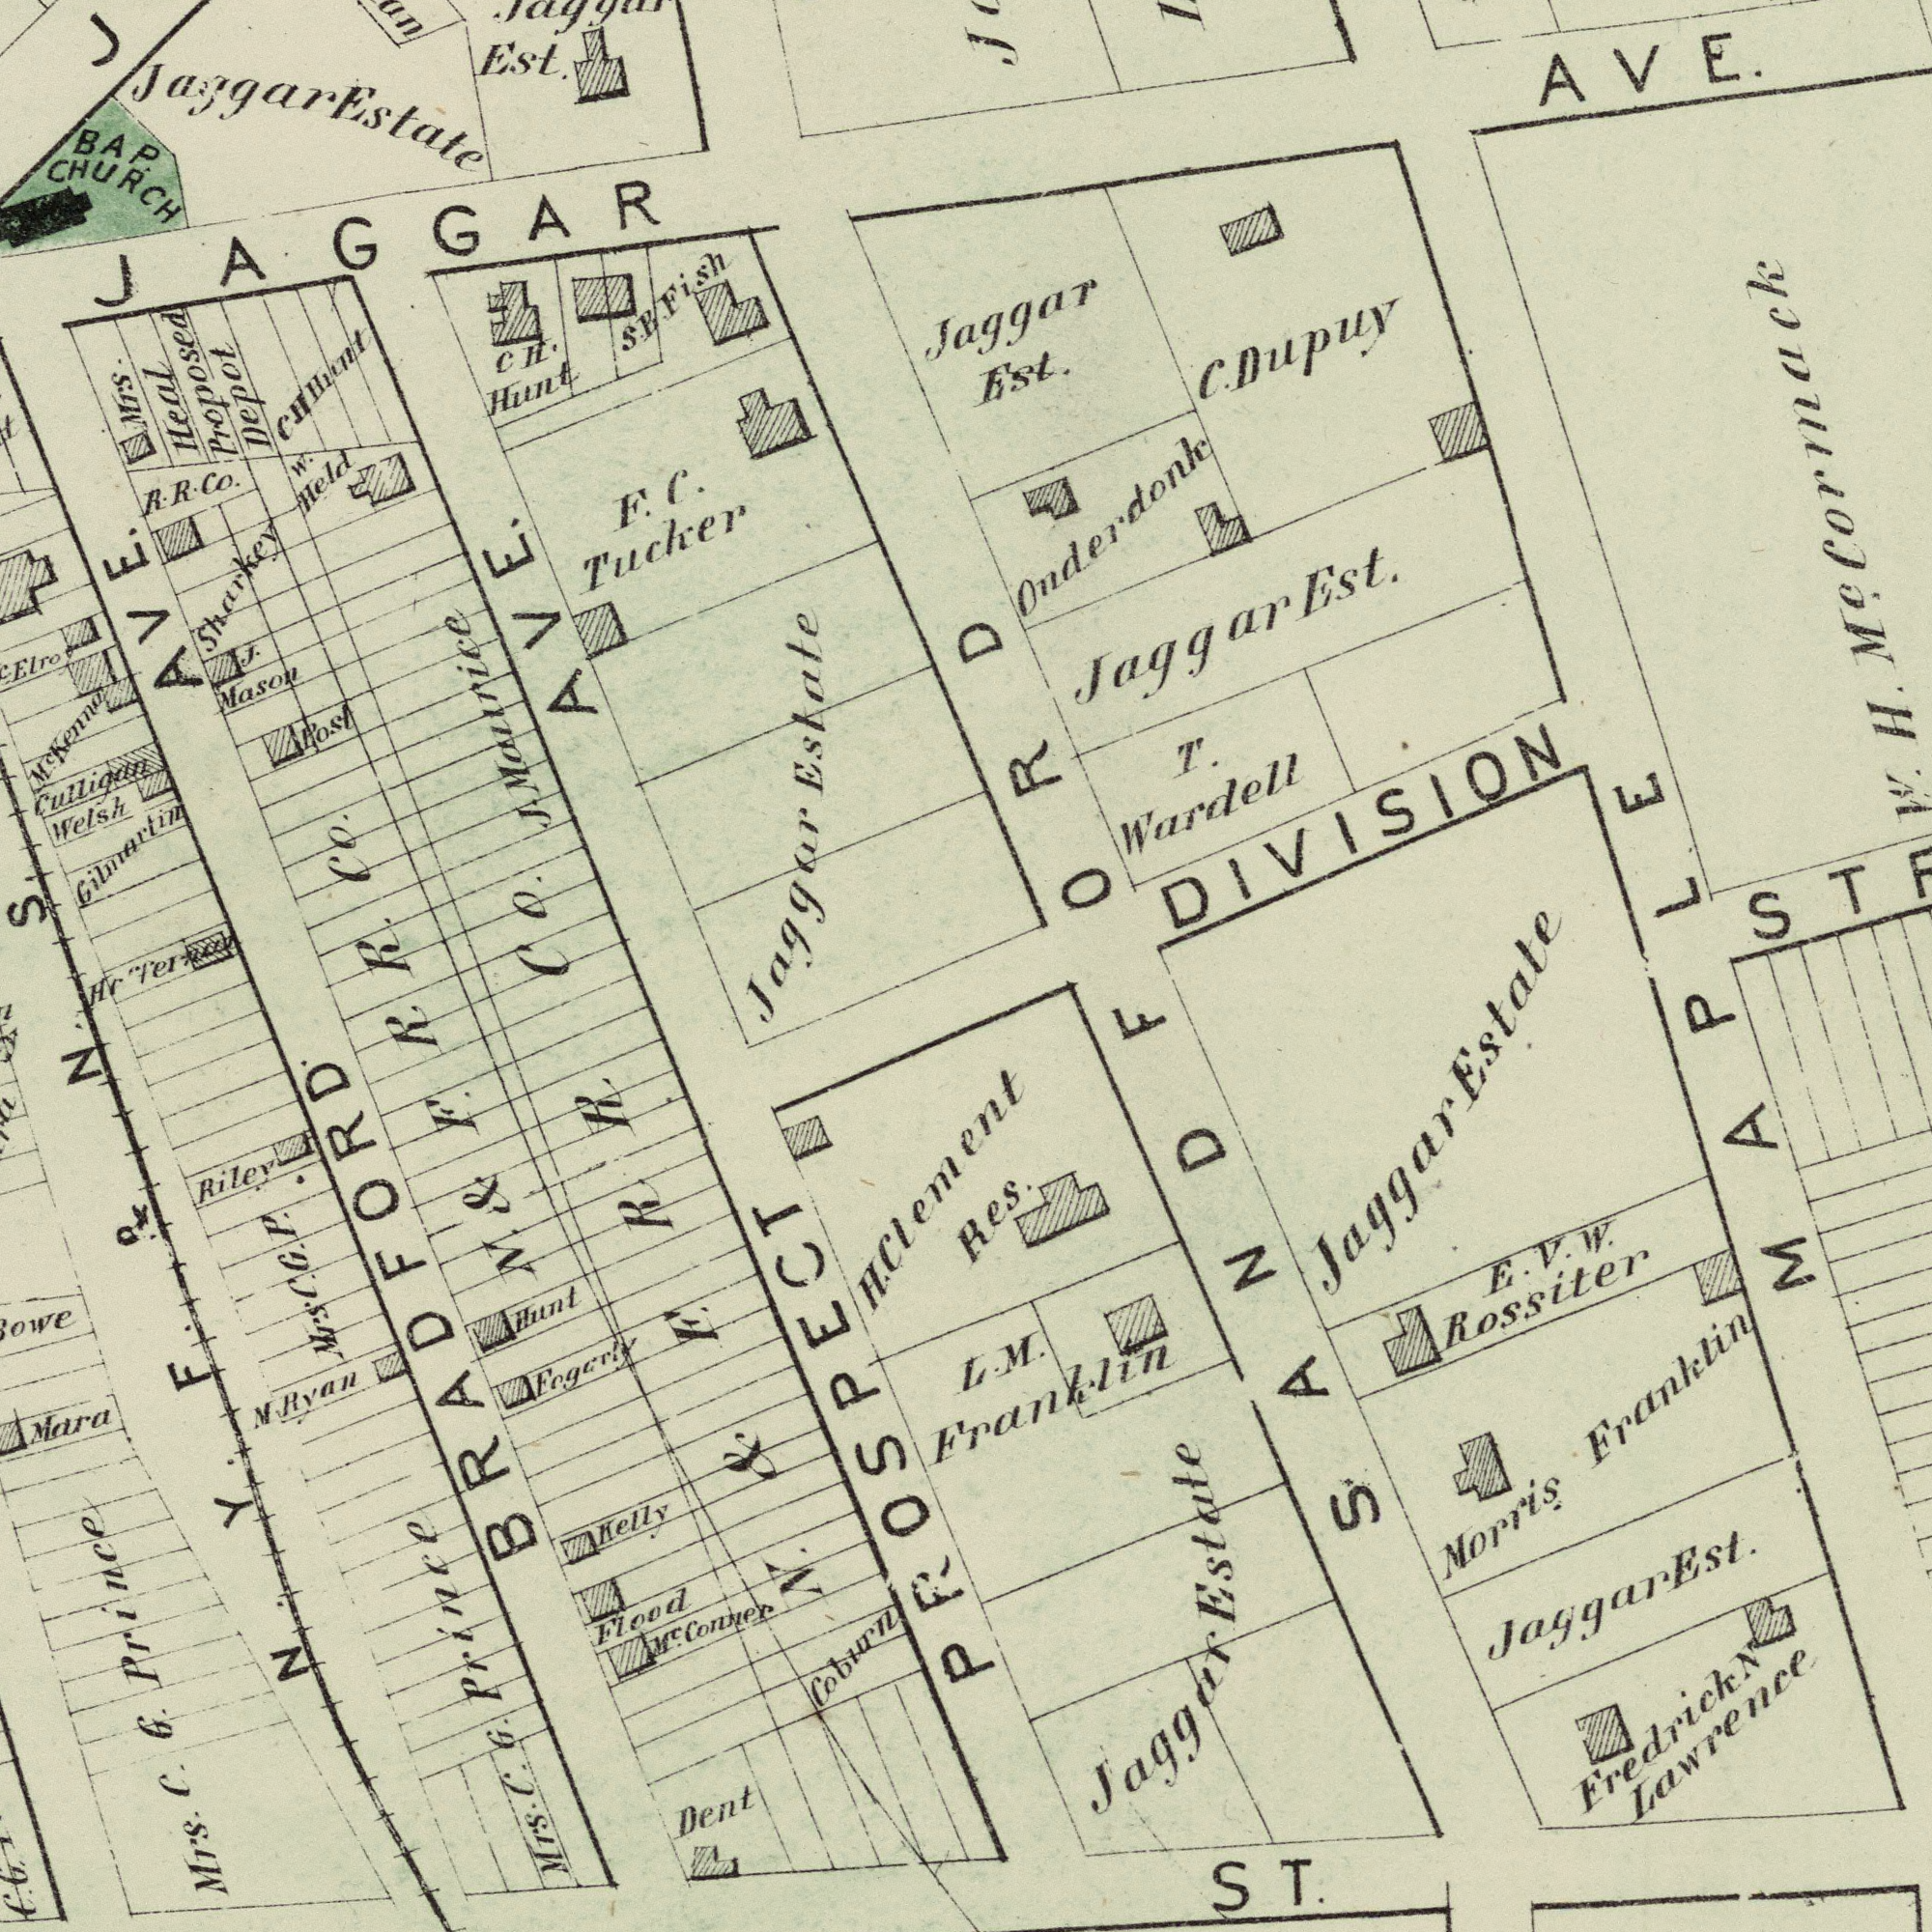What text appears in the top-left area of the image? F. C. Tucker BAP. CHURCH Culligan Welsh Est. W. Held CH. Hunt Gilmartin J. Masou Sharkey Jaggar Estate Post J. Maurice JAGGAR R. R. Co. AVE. Jaggar Estate Mrs. Heal Proposed Depot AVE S. B Fish R. Co. CO. MC Kenna CH H Hiunt S. What text is visible in the lower-left corner? Mara Riley Coburn Mrs. C. G. Prince Helly Dent M Ryan Hr Hunt Flood MC. Conver MTs. C. G. Prince Fogerly H. Clement PROSPECT BRADFORD N. & F. R. N. & E. R. R. Mrs C. G. P. C. G. N. Y. F. R. N. What text appears in the bottom-right area of the image? Morris Franklin Fredrick N. Lawrence Res. E. V. W. Rossiter ST. Jaggar Est. Jaggar Estate L. M. Franklin SANDFORD MAPLE Jaggar Estate What text is shown in the top-right quadrant? AVE. Jaggar Est. Jaggar Est. Onderdonk T. Wardell DIVISION C. Dupuy H. MC. Cormack 